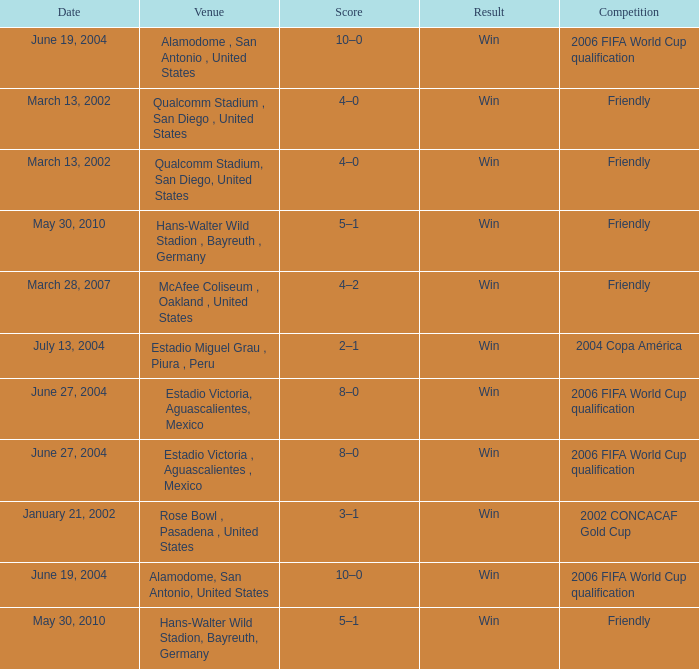What date has alamodome, san antonio, united states as the venue? June 19, 2004, June 19, 2004. 